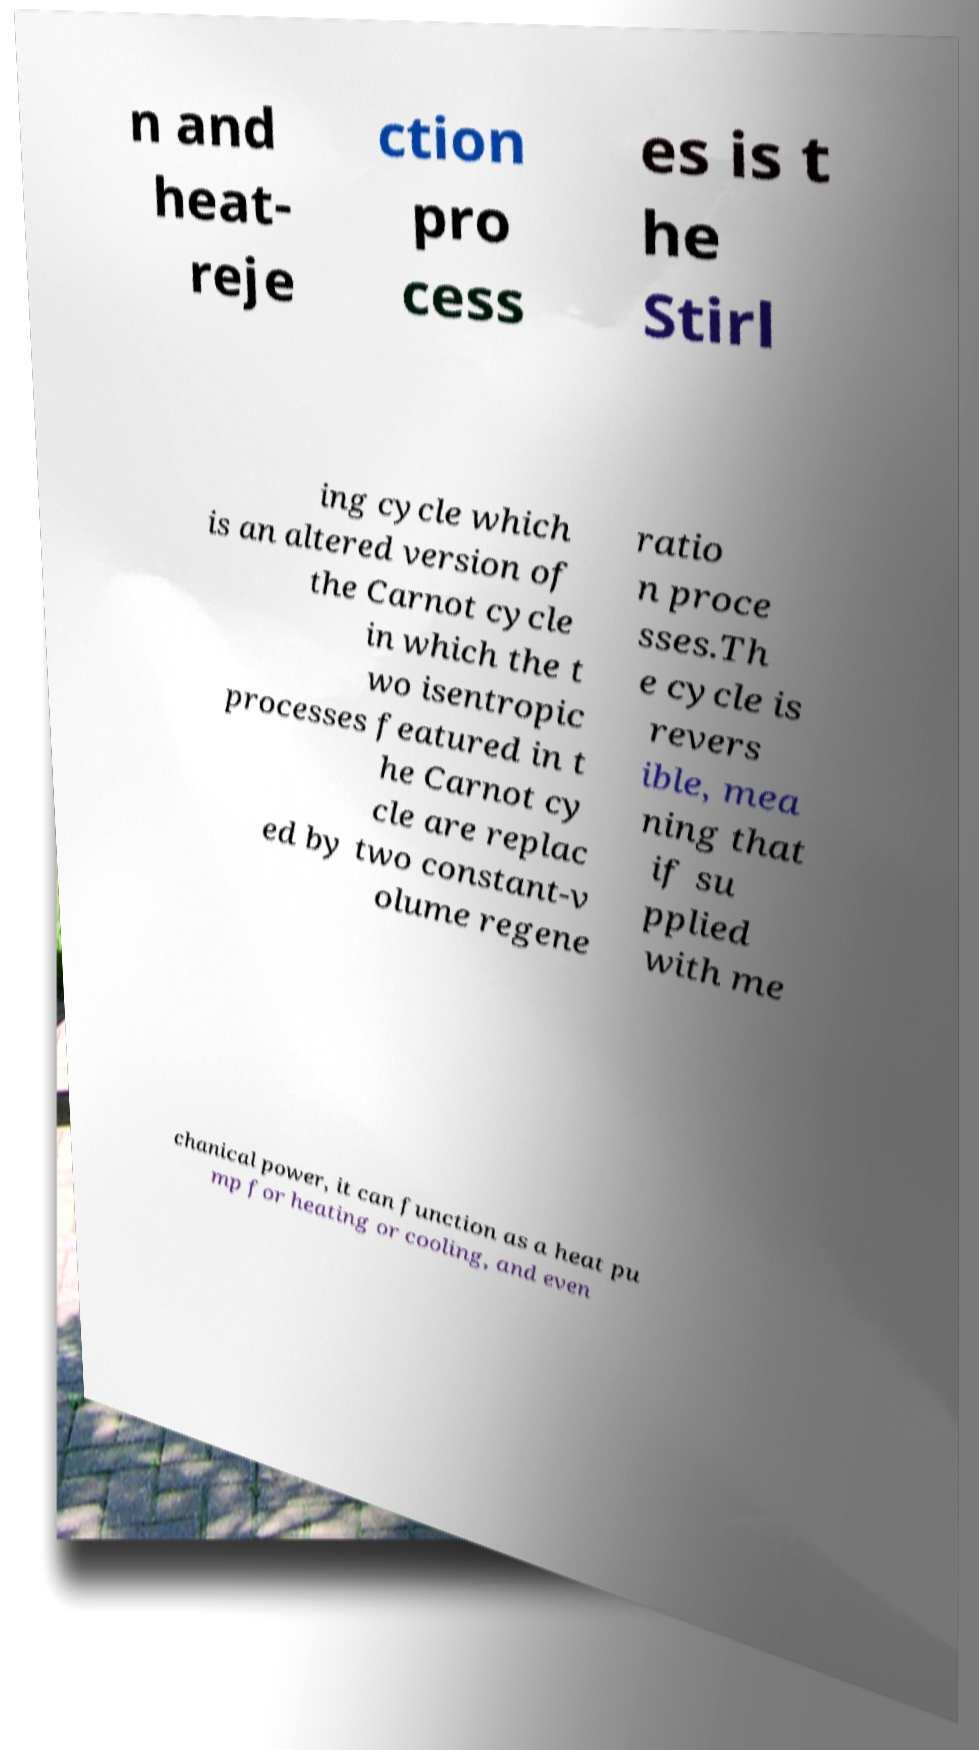Could you extract and type out the text from this image? n and heat- reje ction pro cess es is t he Stirl ing cycle which is an altered version of the Carnot cycle in which the t wo isentropic processes featured in t he Carnot cy cle are replac ed by two constant-v olume regene ratio n proce sses.Th e cycle is revers ible, mea ning that if su pplied with me chanical power, it can function as a heat pu mp for heating or cooling, and even 